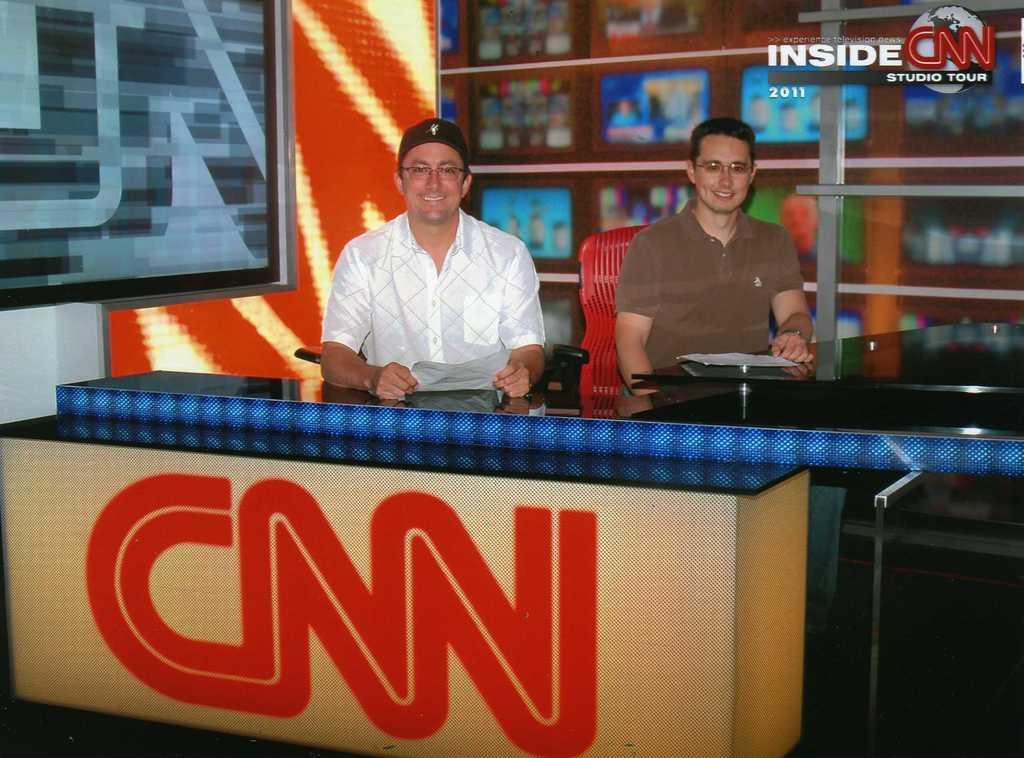How would you summarize this image in a sentence or two? In this image it look like it is a news channel office in which there are two reporters sitting in the chairs by holding the papers. In the background there are so many televisions. 